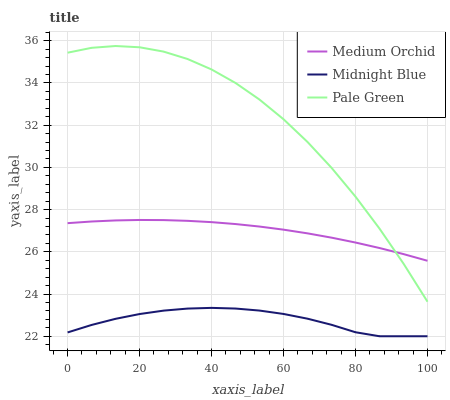Does Midnight Blue have the minimum area under the curve?
Answer yes or no. Yes. Does Pale Green have the maximum area under the curve?
Answer yes or no. Yes. Does Medium Orchid have the minimum area under the curve?
Answer yes or no. No. Does Medium Orchid have the maximum area under the curve?
Answer yes or no. No. Is Medium Orchid the smoothest?
Answer yes or no. Yes. Is Pale Green the roughest?
Answer yes or no. Yes. Is Midnight Blue the smoothest?
Answer yes or no. No. Is Midnight Blue the roughest?
Answer yes or no. No. Does Midnight Blue have the lowest value?
Answer yes or no. Yes. Does Medium Orchid have the lowest value?
Answer yes or no. No. Does Pale Green have the highest value?
Answer yes or no. Yes. Does Medium Orchid have the highest value?
Answer yes or no. No. Is Midnight Blue less than Pale Green?
Answer yes or no. Yes. Is Medium Orchid greater than Midnight Blue?
Answer yes or no. Yes. Does Medium Orchid intersect Pale Green?
Answer yes or no. Yes. Is Medium Orchid less than Pale Green?
Answer yes or no. No. Is Medium Orchid greater than Pale Green?
Answer yes or no. No. Does Midnight Blue intersect Pale Green?
Answer yes or no. No. 